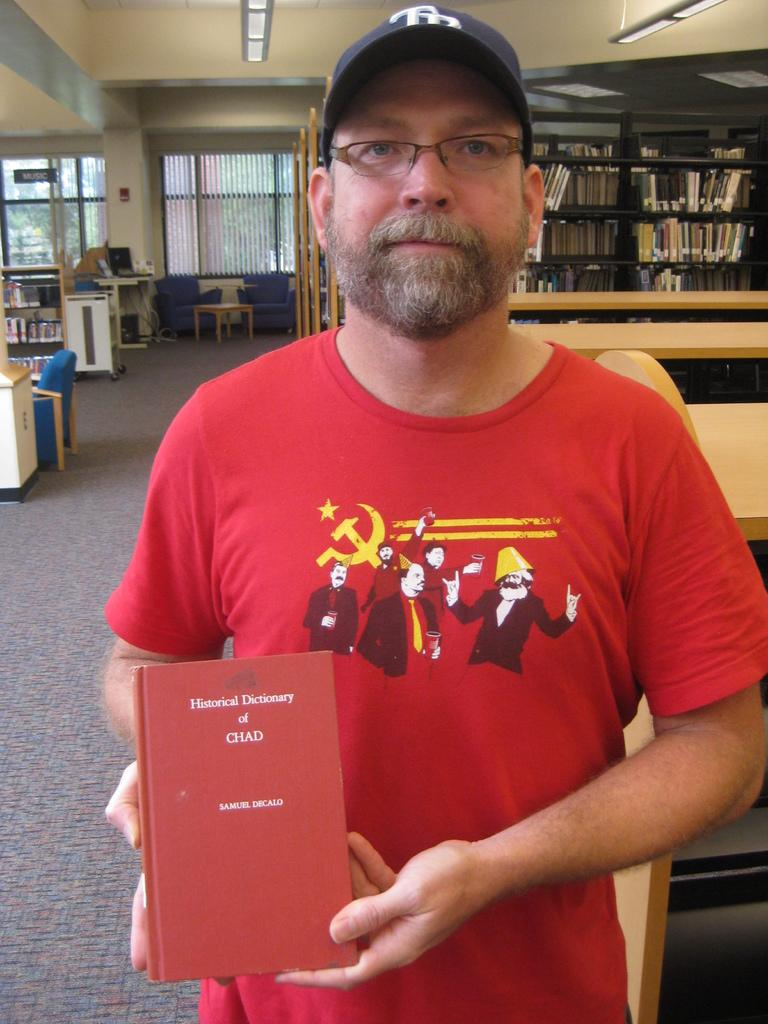<image>
Render a clear and concise summary of the photo. A man in red holds a book titled Historical Dictionary of CHAD. 